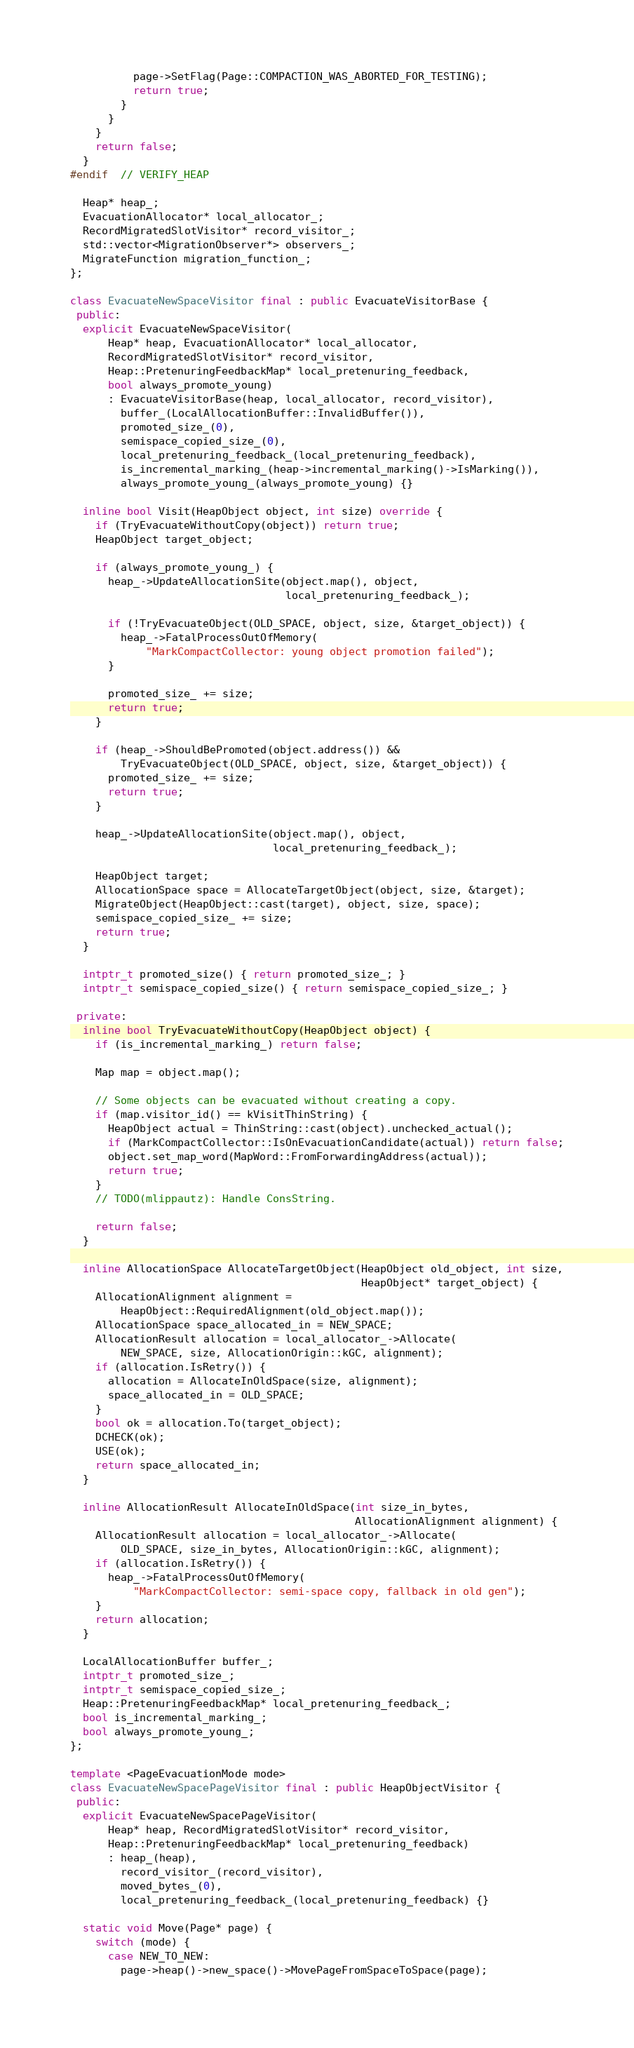<code> <loc_0><loc_0><loc_500><loc_500><_C++_>          page->SetFlag(Page::COMPACTION_WAS_ABORTED_FOR_TESTING);
          return true;
        }
      }
    }
    return false;
  }
#endif  // VERIFY_HEAP

  Heap* heap_;
  EvacuationAllocator* local_allocator_;
  RecordMigratedSlotVisitor* record_visitor_;
  std::vector<MigrationObserver*> observers_;
  MigrateFunction migration_function_;
};

class EvacuateNewSpaceVisitor final : public EvacuateVisitorBase {
 public:
  explicit EvacuateNewSpaceVisitor(
      Heap* heap, EvacuationAllocator* local_allocator,
      RecordMigratedSlotVisitor* record_visitor,
      Heap::PretenuringFeedbackMap* local_pretenuring_feedback,
      bool always_promote_young)
      : EvacuateVisitorBase(heap, local_allocator, record_visitor),
        buffer_(LocalAllocationBuffer::InvalidBuffer()),
        promoted_size_(0),
        semispace_copied_size_(0),
        local_pretenuring_feedback_(local_pretenuring_feedback),
        is_incremental_marking_(heap->incremental_marking()->IsMarking()),
        always_promote_young_(always_promote_young) {}

  inline bool Visit(HeapObject object, int size) override {
    if (TryEvacuateWithoutCopy(object)) return true;
    HeapObject target_object;

    if (always_promote_young_) {
      heap_->UpdateAllocationSite(object.map(), object,
                                  local_pretenuring_feedback_);

      if (!TryEvacuateObject(OLD_SPACE, object, size, &target_object)) {
        heap_->FatalProcessOutOfMemory(
            "MarkCompactCollector: young object promotion failed");
      }

      promoted_size_ += size;
      return true;
    }

    if (heap_->ShouldBePromoted(object.address()) &&
        TryEvacuateObject(OLD_SPACE, object, size, &target_object)) {
      promoted_size_ += size;
      return true;
    }

    heap_->UpdateAllocationSite(object.map(), object,
                                local_pretenuring_feedback_);

    HeapObject target;
    AllocationSpace space = AllocateTargetObject(object, size, &target);
    MigrateObject(HeapObject::cast(target), object, size, space);
    semispace_copied_size_ += size;
    return true;
  }

  intptr_t promoted_size() { return promoted_size_; }
  intptr_t semispace_copied_size() { return semispace_copied_size_; }

 private:
  inline bool TryEvacuateWithoutCopy(HeapObject object) {
    if (is_incremental_marking_) return false;

    Map map = object.map();

    // Some objects can be evacuated without creating a copy.
    if (map.visitor_id() == kVisitThinString) {
      HeapObject actual = ThinString::cast(object).unchecked_actual();
      if (MarkCompactCollector::IsOnEvacuationCandidate(actual)) return false;
      object.set_map_word(MapWord::FromForwardingAddress(actual));
      return true;
    }
    // TODO(mlippautz): Handle ConsString.

    return false;
  }

  inline AllocationSpace AllocateTargetObject(HeapObject old_object, int size,
                                              HeapObject* target_object) {
    AllocationAlignment alignment =
        HeapObject::RequiredAlignment(old_object.map());
    AllocationSpace space_allocated_in = NEW_SPACE;
    AllocationResult allocation = local_allocator_->Allocate(
        NEW_SPACE, size, AllocationOrigin::kGC, alignment);
    if (allocation.IsRetry()) {
      allocation = AllocateInOldSpace(size, alignment);
      space_allocated_in = OLD_SPACE;
    }
    bool ok = allocation.To(target_object);
    DCHECK(ok);
    USE(ok);
    return space_allocated_in;
  }

  inline AllocationResult AllocateInOldSpace(int size_in_bytes,
                                             AllocationAlignment alignment) {
    AllocationResult allocation = local_allocator_->Allocate(
        OLD_SPACE, size_in_bytes, AllocationOrigin::kGC, alignment);
    if (allocation.IsRetry()) {
      heap_->FatalProcessOutOfMemory(
          "MarkCompactCollector: semi-space copy, fallback in old gen");
    }
    return allocation;
  }

  LocalAllocationBuffer buffer_;
  intptr_t promoted_size_;
  intptr_t semispace_copied_size_;
  Heap::PretenuringFeedbackMap* local_pretenuring_feedback_;
  bool is_incremental_marking_;
  bool always_promote_young_;
};

template <PageEvacuationMode mode>
class EvacuateNewSpacePageVisitor final : public HeapObjectVisitor {
 public:
  explicit EvacuateNewSpacePageVisitor(
      Heap* heap, RecordMigratedSlotVisitor* record_visitor,
      Heap::PretenuringFeedbackMap* local_pretenuring_feedback)
      : heap_(heap),
        record_visitor_(record_visitor),
        moved_bytes_(0),
        local_pretenuring_feedback_(local_pretenuring_feedback) {}

  static void Move(Page* page) {
    switch (mode) {
      case NEW_TO_NEW:
        page->heap()->new_space()->MovePageFromSpaceToSpace(page);</code> 